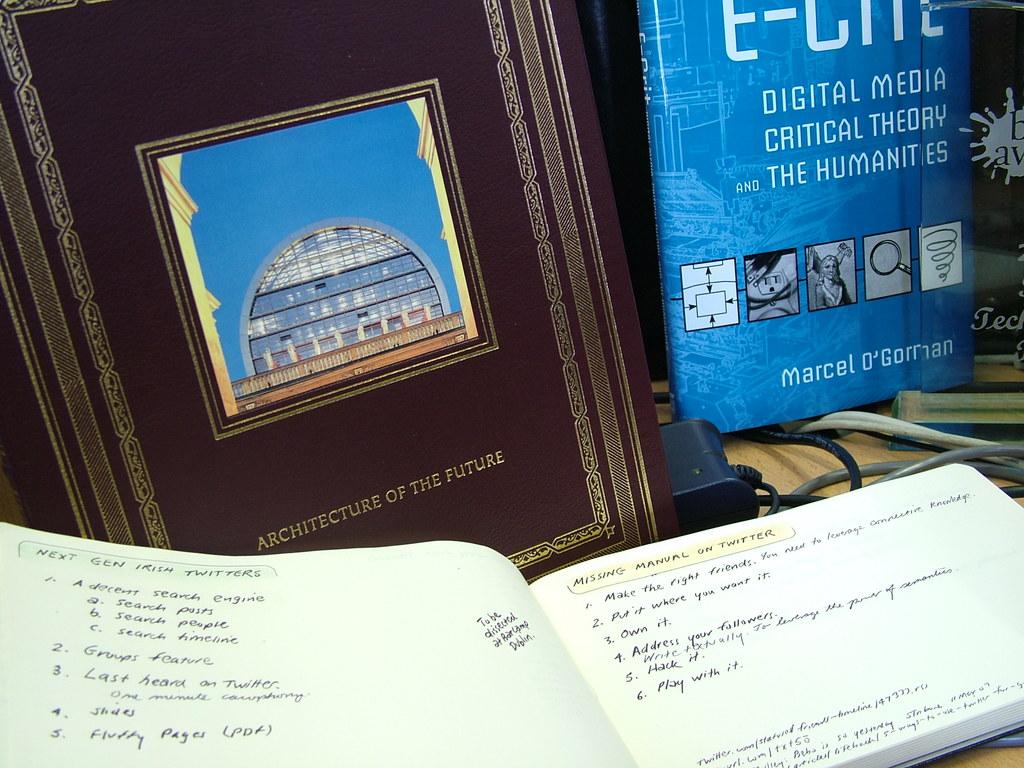What is the title of the work?
Keep it short and to the point. Architecture of the future. 